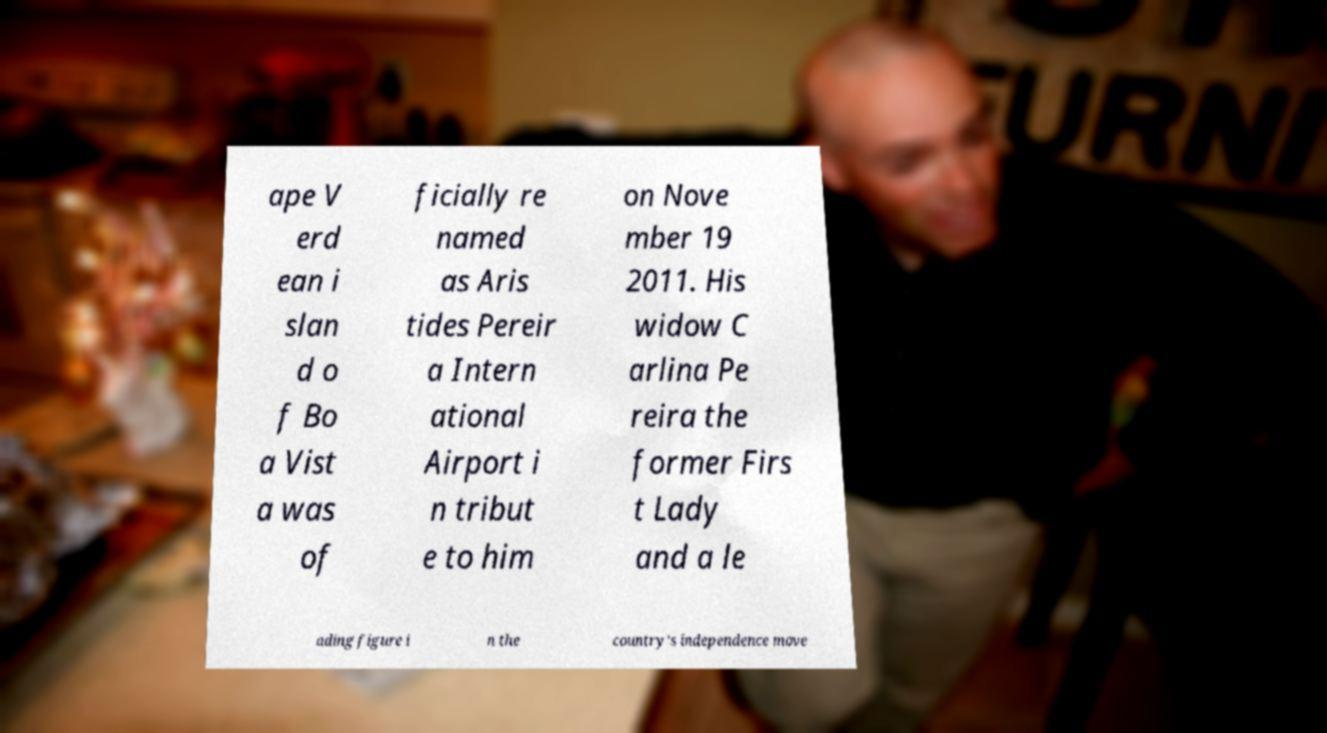There's text embedded in this image that I need extracted. Can you transcribe it verbatim? ape V erd ean i slan d o f Bo a Vist a was of ficially re named as Aris tides Pereir a Intern ational Airport i n tribut e to him on Nove mber 19 2011. His widow C arlina Pe reira the former Firs t Lady and a le ading figure i n the country's independence move 